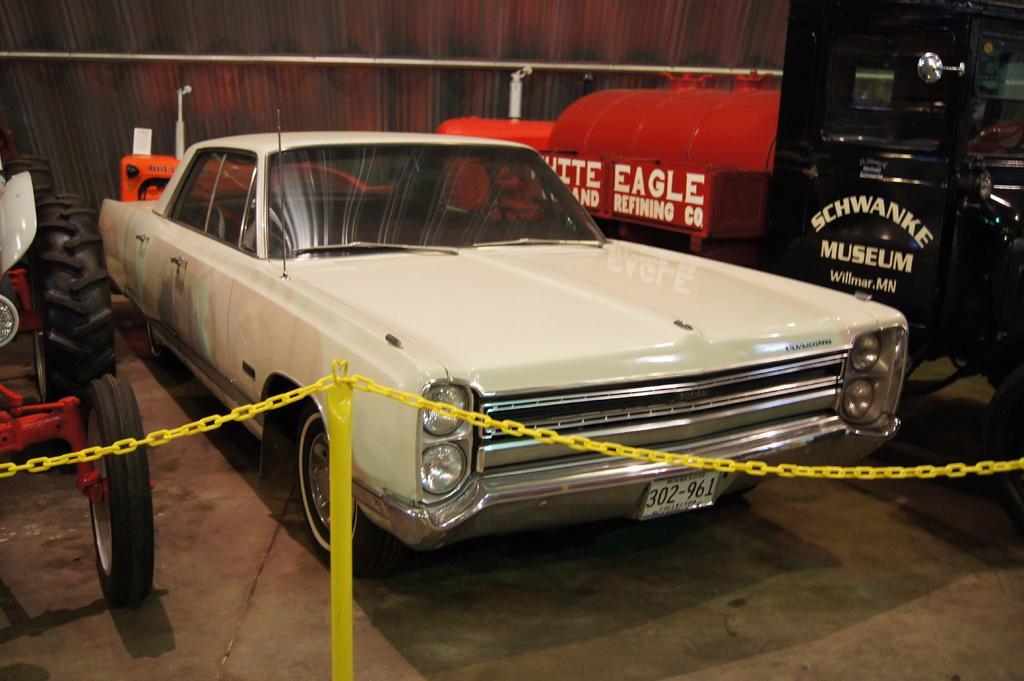Describe this image in one or two sentences. In this image in the front there is a pole and there is a chain. In the background there are vehicles. 